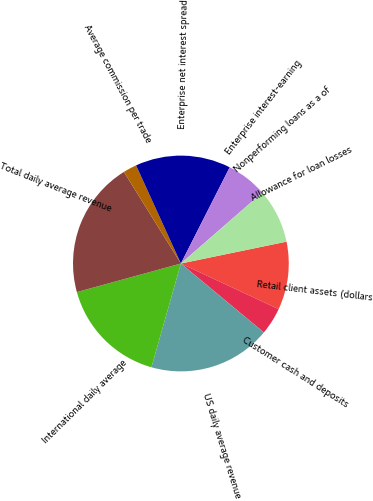Convert chart. <chart><loc_0><loc_0><loc_500><loc_500><pie_chart><fcel>Retail client assets (dollars<fcel>Customer cash and deposits<fcel>US daily average revenue<fcel>International daily average<fcel>Total daily average revenue<fcel>Average commission per trade<fcel>Enterprise net interest spread<fcel>Enterprise interest-earning<fcel>Nonperforming loans as a of<fcel>Allowance for loan losses<nl><fcel>10.2%<fcel>4.08%<fcel>18.37%<fcel>16.33%<fcel>20.41%<fcel>2.04%<fcel>14.29%<fcel>6.12%<fcel>0.0%<fcel>8.16%<nl></chart> 